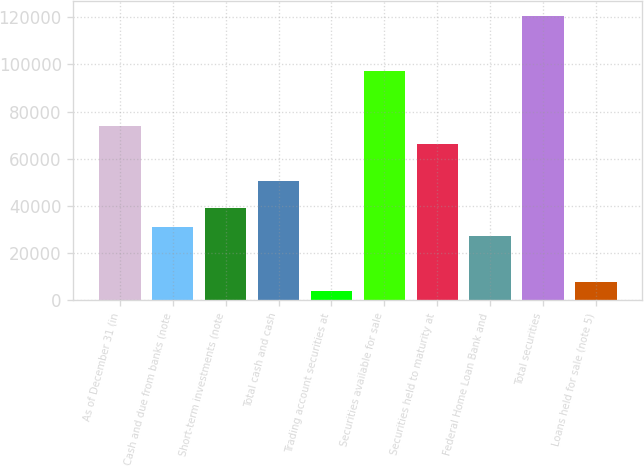<chart> <loc_0><loc_0><loc_500><loc_500><bar_chart><fcel>As of December 31 (in<fcel>Cash and due from banks (note<fcel>Short-term investments (note<fcel>Total cash and cash<fcel>Trading account securities at<fcel>Securities available for sale<fcel>Securities held to maturity at<fcel>Federal Home Loan Bank and<fcel>Total securities<fcel>Loans held for sale (note 5)<nl><fcel>73995.2<fcel>31158.1<fcel>38946.7<fcel>50629.5<fcel>3898.18<fcel>97360.9<fcel>66206.7<fcel>27263.9<fcel>120727<fcel>7792.46<nl></chart> 